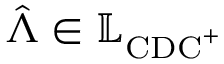<formula> <loc_0><loc_0><loc_500><loc_500>\hat { \Lambda } \in \mathbb { L } _ { C D C ^ { + } }</formula> 